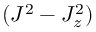<formula> <loc_0><loc_0><loc_500><loc_500>( J ^ { 2 } - J _ { z } ^ { 2 } )</formula> 